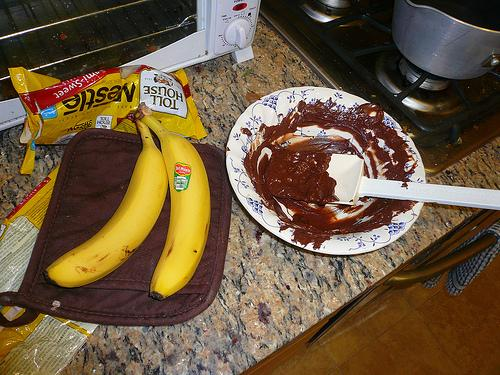Kindly provide a description of the utensil that appears to be covered in chocolate. A white plastic spatula covered in dark chocolate cake frosting is seen in the image. Express your thoughts on the overall sentiment and feeling emanating from the image. The image appears to convey a homey and comforting environment, with cooking and baking ingredients and utensils displayed in a casual manner. Analyze the bananas in terms of their color and any additional details presented. The bananas are yellow and have a green, white, and red sticker on their skin. Elaborate on the appearance of the countertop, mentioning its colors and material. The countertop is multicolored and made of marble, providing a visually appealing backdrop for the objects displayed on it. In a narrative manner, tell me what is happening with the paper plate. Once a white plate with a blue stylized pattern, it is now smeared with melted chocolate as if it was used for stirring or mixing something. What type of bag is in the image and what is inside it? There is a yellow and red plastic bag containing Nestle chocolate chips. Comment on the current state of the spatula and the plate within the context of the image. The white spatula and the plate are both interacting, as the spatula is placed on top of the plate, transferring the chocolate frosting to it. What type of fruits are on display in the image? There are a pair of ripe bananas in the image. Can you count and tell me how many items are involved in the heating or cooking process in the image? There are three items: a blue metal cook pot, a silver pot on a black stove burner, and the burner of a gas stove. Please describe the positioning of brown pot holder in the image. The brown oven mitt is lying on the corner with a pair of bananas laying on it. Can you please check if there is a green plastic bag of Nestle chocolate chips? There is no "green plastic bag" in the image; the actual object color in the image is yellow. Can you find a white paper plate with no design on it? The image features a "white plate with blue stylized pattern" and a "blue pattern on white paper plate," so there is no plain white paper plate in the image. Is there a black microwave oven in the image? The microwave oven present in the image is "white," not black. Is the spatula on the plate made of wood instead of plastic? The image contains a "white plastic spatula" rather than a wooden spatula. Are the bananas on the oven mitt completely green and unripe? The bananas in the image are described as "ripe" and "yellow," not green and unripe. Can you see the pink oven mitt on the corner? The oven mitt in the image is described as a "dark brown pot holder," not a pink oven mitt. 